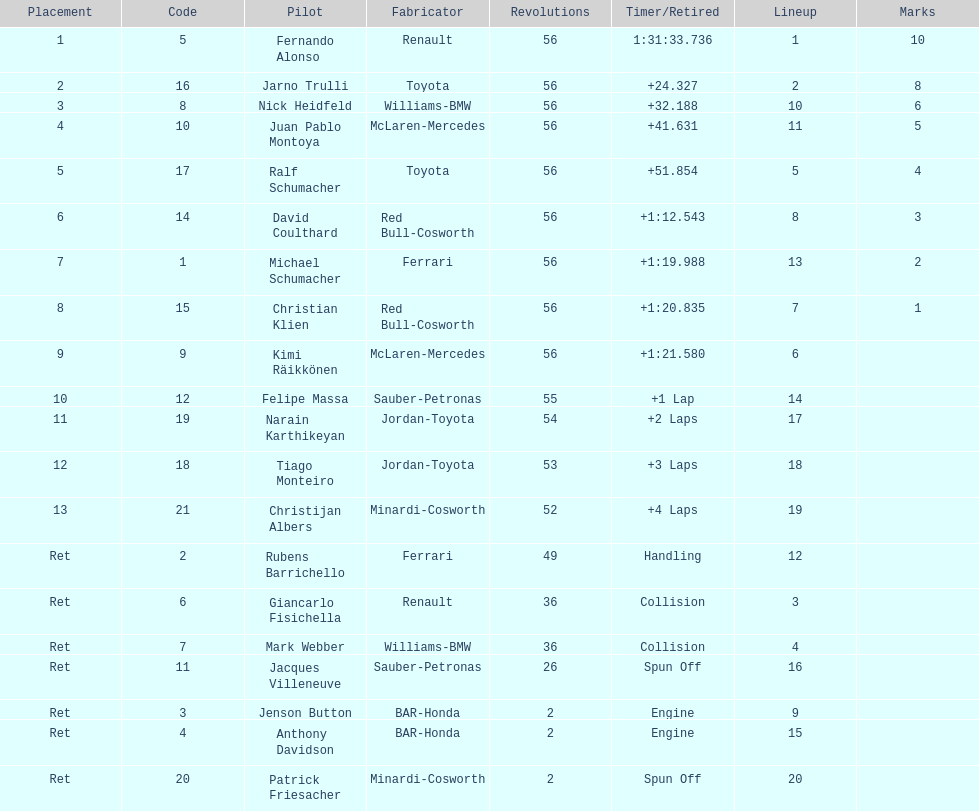What driver finished first? Fernando Alonso. 